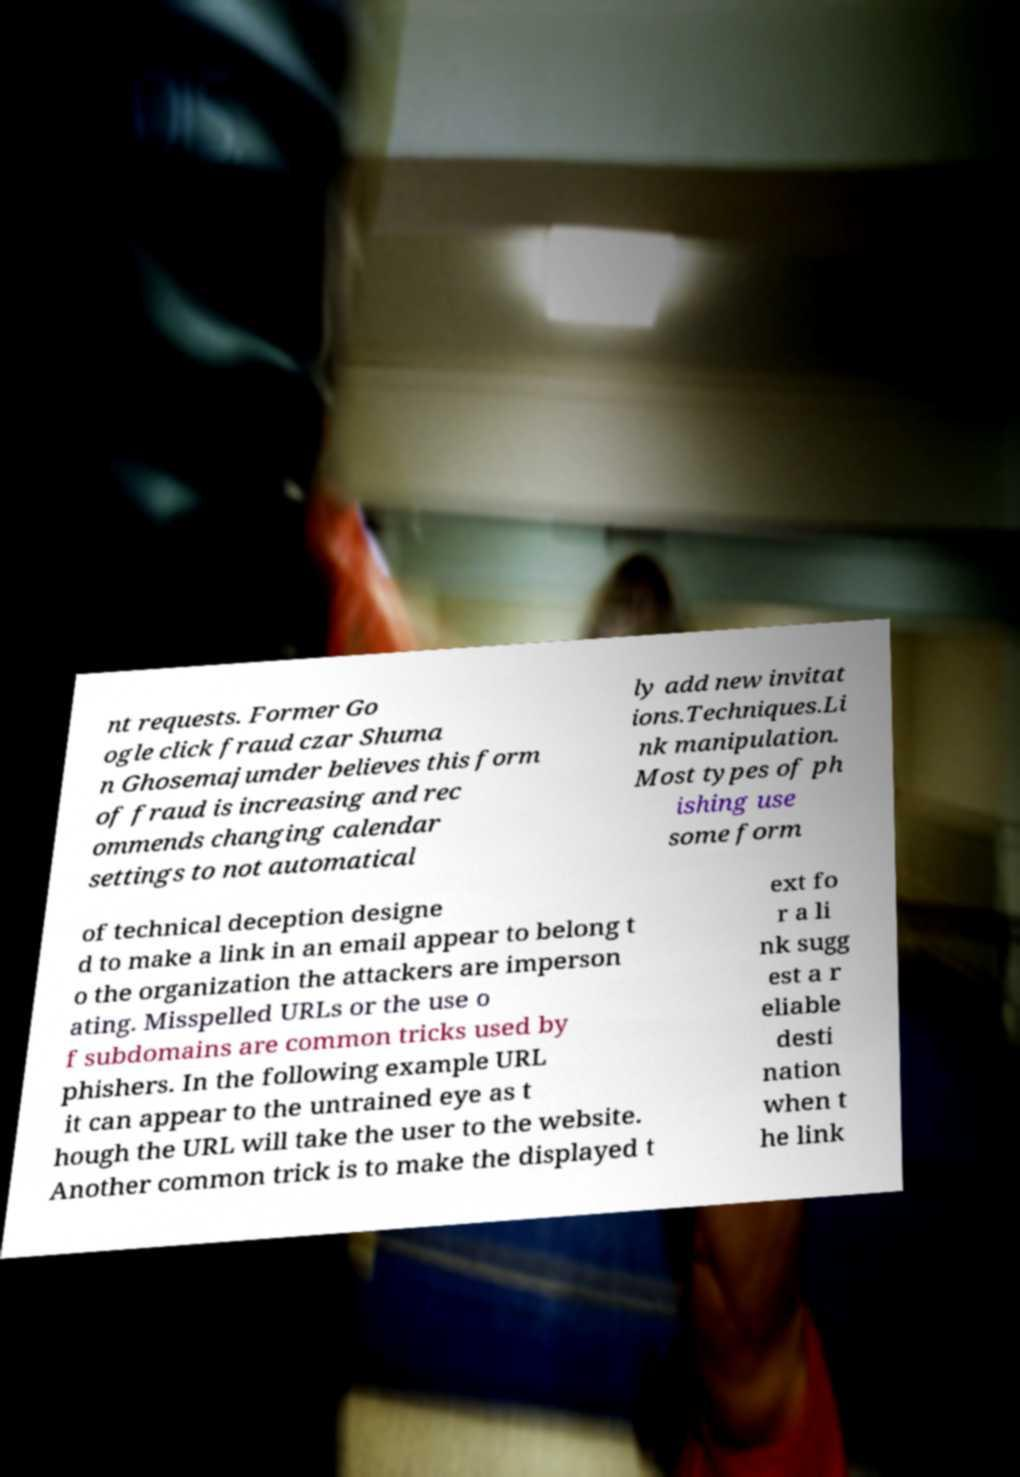There's text embedded in this image that I need extracted. Can you transcribe it verbatim? nt requests. Former Go ogle click fraud czar Shuma n Ghosemajumder believes this form of fraud is increasing and rec ommends changing calendar settings to not automatical ly add new invitat ions.Techniques.Li nk manipulation. Most types of ph ishing use some form of technical deception designe d to make a link in an email appear to belong t o the organization the attackers are imperson ating. Misspelled URLs or the use o f subdomains are common tricks used by phishers. In the following example URL it can appear to the untrained eye as t hough the URL will take the user to the website. Another common trick is to make the displayed t ext fo r a li nk sugg est a r eliable desti nation when t he link 